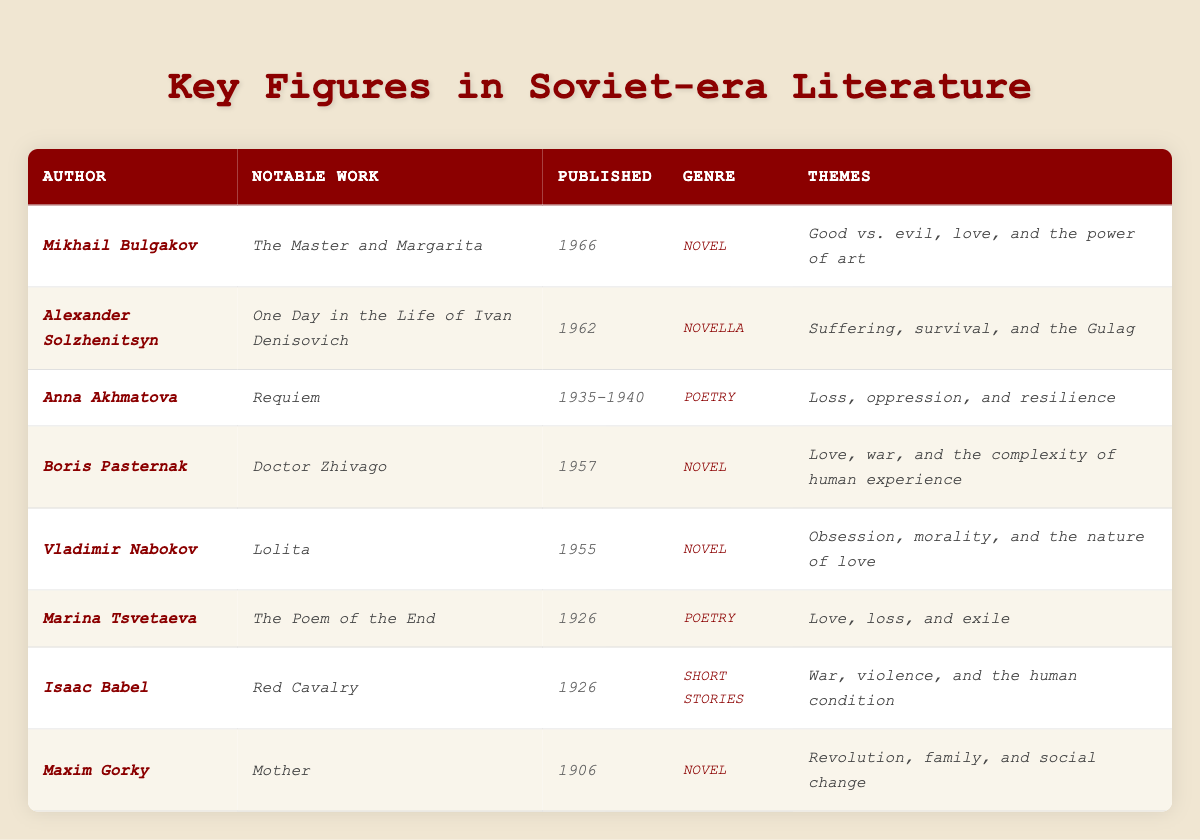What is the most notable work of Mikhail Bulgakov? According to the table, the most notable work of Mikhail Bulgakov is *The Master and Margarita*.
Answer: *The Master and Margarita* Which author published their notable work in 1962? The table indicates that Alexander Solzhenitsyn published *One Day in the Life of Ivan Denisovich* in 1962.
Answer: Alexander Solzhenitsyn What are the themes of Boris Pasternak's *Doctor Zhivago*? The table lists the themes of *Doctor Zhivago* as love, war, and the complexity of human experience.
Answer: Love, war, and the complexity of human experience How many authors in the table have published works classified as poetry? There are three authors listed with works classified as poetry: Anna Akhmatova, Marina Tsvetaeva, and their notable works are Requiem and The Poem of the End, respectively.
Answer: 3 What is the genre of *Lolita*? The table indicates that the genre of *Lolita* is a novel.
Answer: Novel Which themes are common between *Red Cavalry* and *Requiem*? Both works share themes related to suffering and loss, with *Red Cavalry* focusing on war and the human condition and *Requiem* addressing loss and oppression.
Answer: Suffering and loss Did any of the listed authors publish their works before 1930? Yes, Maxim Gorky published *Mother* in 1906, which is before 1930.
Answer: Yes Who authored the work that explores the themes of obsession and morality? The table states that Vladimir Nabokov authored *Lolita*, which explores themes of obsession and morality.
Answer: Vladimir Nabokov What is the time period during which Anna Akhmatova's *Requiem* was published? According to the table, *Requiem* was published between 1935 and 1940.
Answer: 1935-1940 Which notable work was published last among the listed authors? The table shows that *The Master and Margarita* by Mikhail Bulgakov was published last in 1966.
Answer: *The Master and Margarita* How many of the authors' notable works deal with themes related to war? The authors with notable works dealing with themes related to war are Boris Pasternak (*Doctor Zhivago*), Isaac Babel (*Red Cavalry*), and Alexander Solzhenitsyn (*One Day in the Life of Ivan Denisovich*), making a total of three.
Answer: 3 What genres of literature are represented in the table? The table presents novels, novellas, poetry, and short stories as the genres represented.
Answer: Novels, novellas, poetry, and short stories Which author wrote about the themes of love, loss, and exile? The table indicates that Marina Tsvetaeva wrote about the themes of love, loss, and exile in *The Poem of the End*.
Answer: Marina Tsvetaeva Can you identify any author known for writing about social change? Maxim Gorky is known for writing about social change in his notable work *Mother*.
Answer: Maxim Gorky What is the earliest published work listed in the table? The table lists *Mother* by Maxim Gorky, published in 1906, as the earliest work.
Answer: *Mother* 